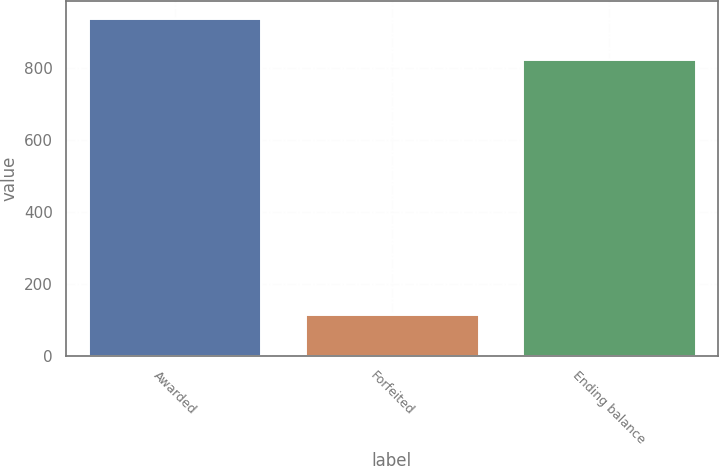Convert chart. <chart><loc_0><loc_0><loc_500><loc_500><bar_chart><fcel>Awarded<fcel>Forfeited<fcel>Ending balance<nl><fcel>941<fcel>116<fcel>825<nl></chart> 